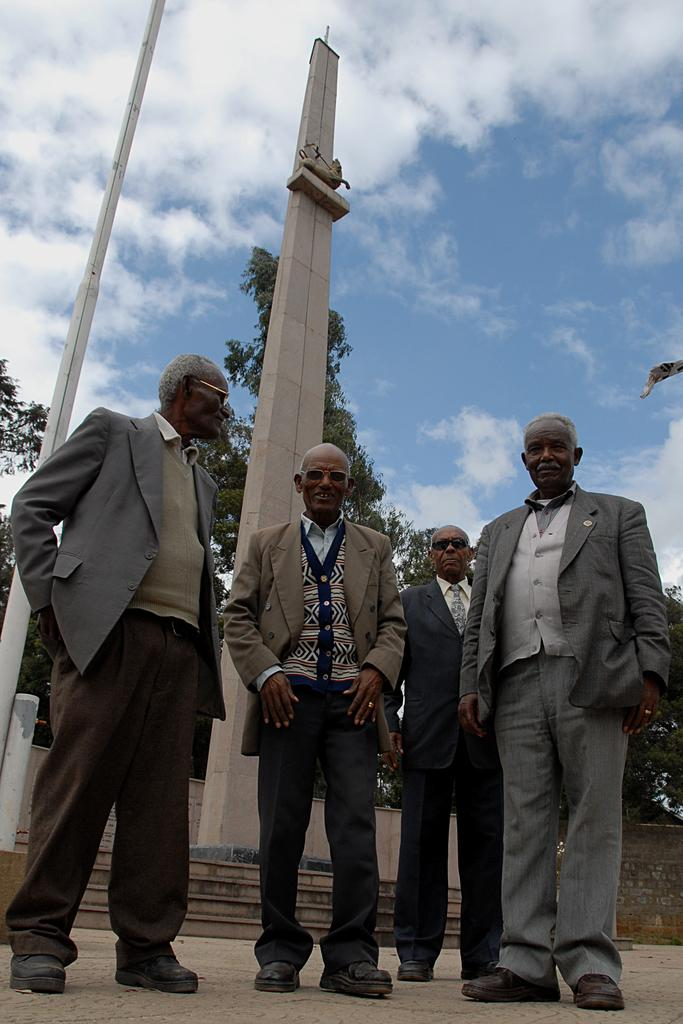How many men are in the image? There are four old men in the image. What are the men wearing? The men are wearing suits. Where are the men standing in relation to the pillar? The men are standing behind the pillar. Can you describe the location of the pillar? The pillar is in the middle of steps. What can be seen behind the pillar? Trees are visible behind the pillar. What is visible above the pillar? The sky is visible above the pillar. What can be observed in the sky? Clouds are present in the sky. What type of disease is affecting the men in the image? There is no indication of any disease affecting the men in the image. What is the men using to drink water in the image? There is no cup or any other drinking vessel present in the image. 